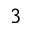Convert formula to latex. <formula><loc_0><loc_0><loc_500><loc_500>^ { 3 }</formula> 